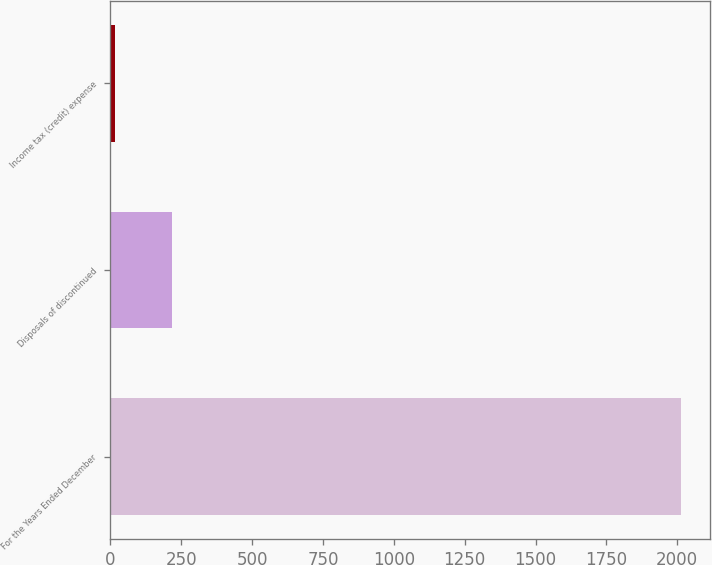Convert chart. <chart><loc_0><loc_0><loc_500><loc_500><bar_chart><fcel>For the Years Ended December<fcel>Disposals of discontinued<fcel>Income tax (credit) expense<nl><fcel>2014<fcel>215.8<fcel>16<nl></chart> 